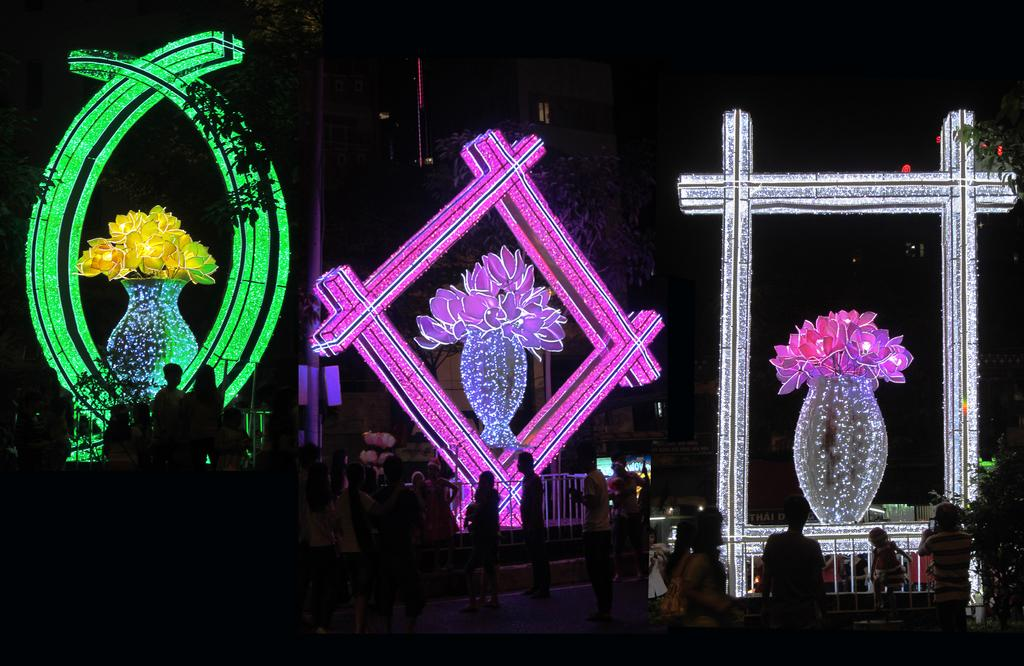What is located in the foreground of the image? There are people in the foreground of the image. What can be seen in the background of the image? There are lights in the shape of a flower pot and buildings in the background of the image. How would you describe the lighting in the background? The background of the image is dark. What type of fork can be seen being used by the people in the image? There is no fork visible in the image; the people are not using any utensils. Can you describe the carriage that the people are riding in the image? There is no carriage present in the image; the people are standing on the ground. 